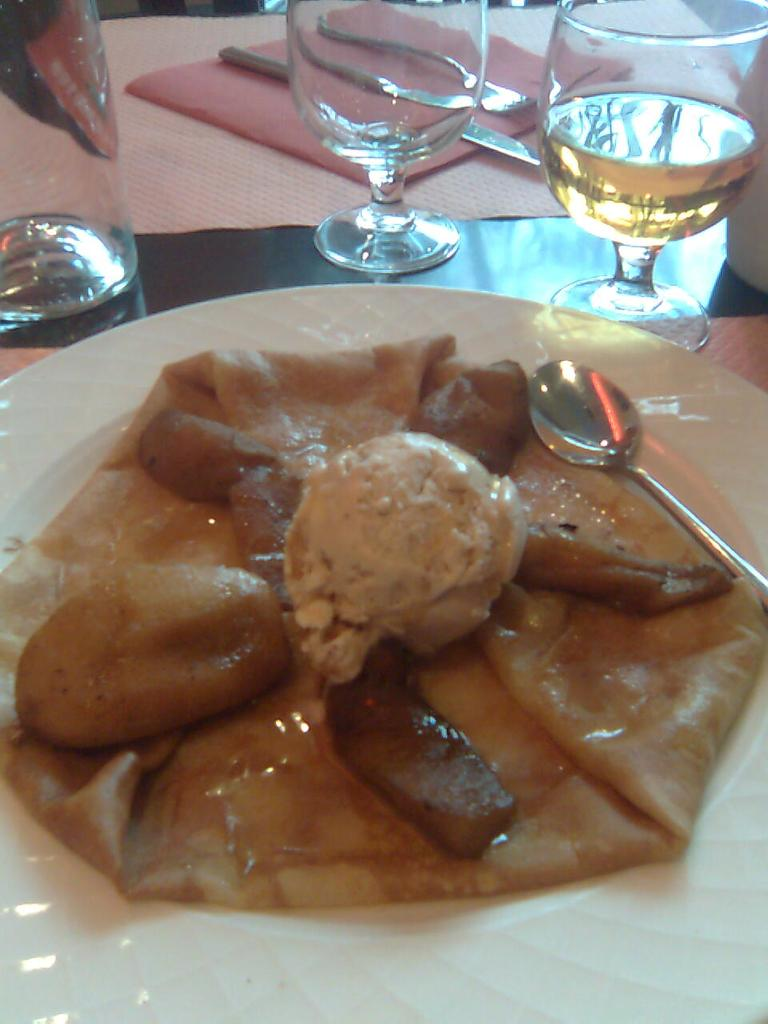What is the main food item visible in the image? There is a food item in the image, but the specific type cannot be determined from the provided facts. What utensil is present in the image? There is a spoon in the image. What is the spoon placed on? The spoon is in a white color plate. What items are located at the top of the image? There are glasses, a knife, a fork, a cloth, and a napkin at the top of the image. How many fairies are dancing around the food item in the image? There are no fairies present in the image. What impulse caused the food item to be placed in the image? The provided facts do not give any information about the reason or impulse behind placing the food item in the image. 